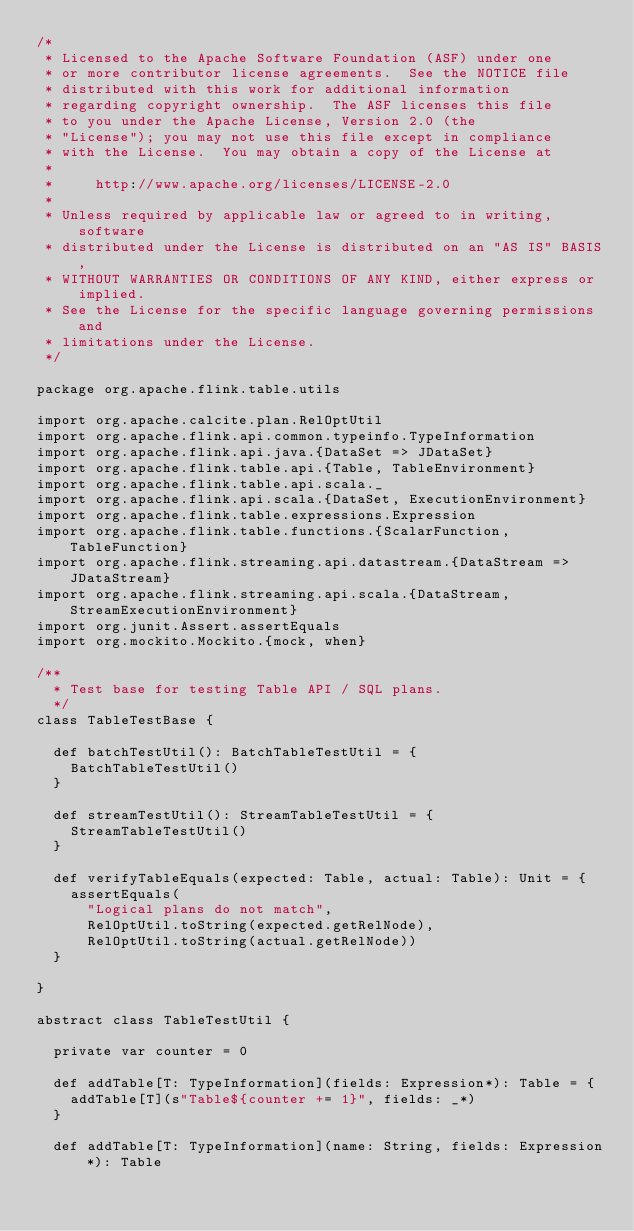Convert code to text. <code><loc_0><loc_0><loc_500><loc_500><_Scala_>/*
 * Licensed to the Apache Software Foundation (ASF) under one
 * or more contributor license agreements.  See the NOTICE file
 * distributed with this work for additional information
 * regarding copyright ownership.  The ASF licenses this file
 * to you under the Apache License, Version 2.0 (the
 * "License"); you may not use this file except in compliance
 * with the License.  You may obtain a copy of the License at
 *
 *     http://www.apache.org/licenses/LICENSE-2.0
 *
 * Unless required by applicable law or agreed to in writing, software
 * distributed under the License is distributed on an "AS IS" BASIS,
 * WITHOUT WARRANTIES OR CONDITIONS OF ANY KIND, either express or implied.
 * See the License for the specific language governing permissions and
 * limitations under the License.
 */

package org.apache.flink.table.utils

import org.apache.calcite.plan.RelOptUtil
import org.apache.flink.api.common.typeinfo.TypeInformation
import org.apache.flink.api.java.{DataSet => JDataSet}
import org.apache.flink.table.api.{Table, TableEnvironment}
import org.apache.flink.table.api.scala._
import org.apache.flink.api.scala.{DataSet, ExecutionEnvironment}
import org.apache.flink.table.expressions.Expression
import org.apache.flink.table.functions.{ScalarFunction, TableFunction}
import org.apache.flink.streaming.api.datastream.{DataStream => JDataStream}
import org.apache.flink.streaming.api.scala.{DataStream, StreamExecutionEnvironment}
import org.junit.Assert.assertEquals
import org.mockito.Mockito.{mock, when}

/**
  * Test base for testing Table API / SQL plans.
  */
class TableTestBase {

  def batchTestUtil(): BatchTableTestUtil = {
    BatchTableTestUtil()
  }

  def streamTestUtil(): StreamTableTestUtil = {
    StreamTableTestUtil()
  }

  def verifyTableEquals(expected: Table, actual: Table): Unit = {
    assertEquals(
      "Logical plans do not match",
      RelOptUtil.toString(expected.getRelNode),
      RelOptUtil.toString(actual.getRelNode))
  }

}

abstract class TableTestUtil {

  private var counter = 0

  def addTable[T: TypeInformation](fields: Expression*): Table = {
    addTable[T](s"Table${counter += 1}", fields: _*)
  }

  def addTable[T: TypeInformation](name: String, fields: Expression*): Table</code> 